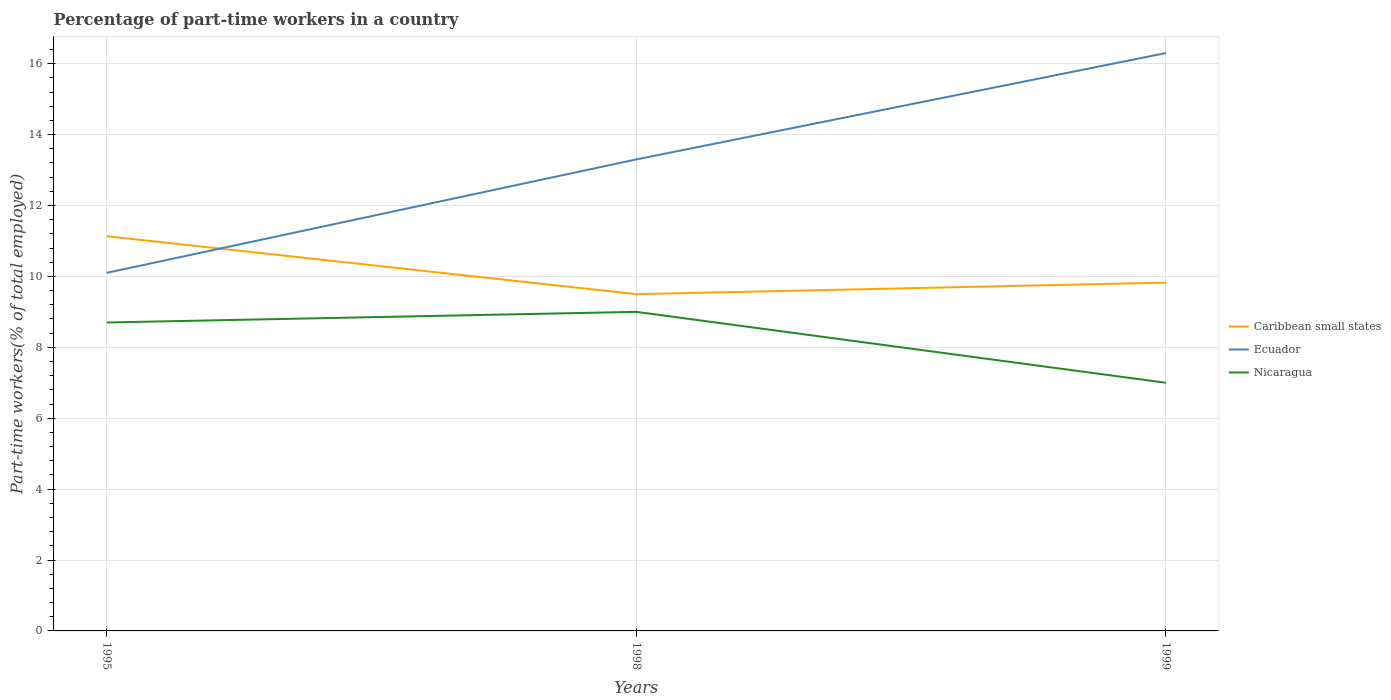How many different coloured lines are there?
Offer a very short reply. 3. Across all years, what is the maximum percentage of part-time workers in Ecuador?
Provide a succinct answer. 10.1. In which year was the percentage of part-time workers in Caribbean small states maximum?
Offer a terse response. 1998. What is the total percentage of part-time workers in Ecuador in the graph?
Provide a short and direct response. -3. What is the difference between the highest and the second highest percentage of part-time workers in Nicaragua?
Provide a short and direct response. 2. How many lines are there?
Keep it short and to the point. 3. What is the difference between two consecutive major ticks on the Y-axis?
Make the answer very short. 2. Are the values on the major ticks of Y-axis written in scientific E-notation?
Provide a short and direct response. No. Does the graph contain grids?
Your answer should be very brief. Yes. Where does the legend appear in the graph?
Keep it short and to the point. Center right. How many legend labels are there?
Your response must be concise. 3. What is the title of the graph?
Give a very brief answer. Percentage of part-time workers in a country. Does "Guatemala" appear as one of the legend labels in the graph?
Offer a terse response. No. What is the label or title of the Y-axis?
Your answer should be very brief. Part-time workers(% of total employed). What is the Part-time workers(% of total employed) of Caribbean small states in 1995?
Ensure brevity in your answer.  11.13. What is the Part-time workers(% of total employed) of Ecuador in 1995?
Ensure brevity in your answer.  10.1. What is the Part-time workers(% of total employed) of Nicaragua in 1995?
Keep it short and to the point. 8.7. What is the Part-time workers(% of total employed) in Caribbean small states in 1998?
Your response must be concise. 9.5. What is the Part-time workers(% of total employed) in Ecuador in 1998?
Your answer should be compact. 13.3. What is the Part-time workers(% of total employed) in Caribbean small states in 1999?
Your answer should be compact. 9.82. What is the Part-time workers(% of total employed) in Ecuador in 1999?
Offer a terse response. 16.3. What is the Part-time workers(% of total employed) in Nicaragua in 1999?
Your answer should be very brief. 7. Across all years, what is the maximum Part-time workers(% of total employed) in Caribbean small states?
Ensure brevity in your answer.  11.13. Across all years, what is the maximum Part-time workers(% of total employed) of Ecuador?
Your answer should be compact. 16.3. Across all years, what is the maximum Part-time workers(% of total employed) in Nicaragua?
Provide a succinct answer. 9. Across all years, what is the minimum Part-time workers(% of total employed) of Caribbean small states?
Offer a terse response. 9.5. Across all years, what is the minimum Part-time workers(% of total employed) in Ecuador?
Offer a very short reply. 10.1. Across all years, what is the minimum Part-time workers(% of total employed) in Nicaragua?
Ensure brevity in your answer.  7. What is the total Part-time workers(% of total employed) of Caribbean small states in the graph?
Ensure brevity in your answer.  30.46. What is the total Part-time workers(% of total employed) of Ecuador in the graph?
Make the answer very short. 39.7. What is the total Part-time workers(% of total employed) of Nicaragua in the graph?
Ensure brevity in your answer.  24.7. What is the difference between the Part-time workers(% of total employed) of Caribbean small states in 1995 and that in 1998?
Your answer should be compact. 1.64. What is the difference between the Part-time workers(% of total employed) in Ecuador in 1995 and that in 1998?
Your answer should be very brief. -3.2. What is the difference between the Part-time workers(% of total employed) in Nicaragua in 1995 and that in 1998?
Your answer should be compact. -0.3. What is the difference between the Part-time workers(% of total employed) in Caribbean small states in 1995 and that in 1999?
Make the answer very short. 1.31. What is the difference between the Part-time workers(% of total employed) of Ecuador in 1995 and that in 1999?
Your answer should be very brief. -6.2. What is the difference between the Part-time workers(% of total employed) in Caribbean small states in 1998 and that in 1999?
Provide a short and direct response. -0.33. What is the difference between the Part-time workers(% of total employed) of Nicaragua in 1998 and that in 1999?
Provide a succinct answer. 2. What is the difference between the Part-time workers(% of total employed) of Caribbean small states in 1995 and the Part-time workers(% of total employed) of Ecuador in 1998?
Your answer should be very brief. -2.17. What is the difference between the Part-time workers(% of total employed) of Caribbean small states in 1995 and the Part-time workers(% of total employed) of Nicaragua in 1998?
Your answer should be compact. 2.13. What is the difference between the Part-time workers(% of total employed) in Ecuador in 1995 and the Part-time workers(% of total employed) in Nicaragua in 1998?
Your answer should be very brief. 1.1. What is the difference between the Part-time workers(% of total employed) in Caribbean small states in 1995 and the Part-time workers(% of total employed) in Ecuador in 1999?
Offer a terse response. -5.17. What is the difference between the Part-time workers(% of total employed) in Caribbean small states in 1995 and the Part-time workers(% of total employed) in Nicaragua in 1999?
Your response must be concise. 4.13. What is the difference between the Part-time workers(% of total employed) of Caribbean small states in 1998 and the Part-time workers(% of total employed) of Ecuador in 1999?
Your answer should be very brief. -6.8. What is the difference between the Part-time workers(% of total employed) of Caribbean small states in 1998 and the Part-time workers(% of total employed) of Nicaragua in 1999?
Give a very brief answer. 2.5. What is the difference between the Part-time workers(% of total employed) of Ecuador in 1998 and the Part-time workers(% of total employed) of Nicaragua in 1999?
Your answer should be very brief. 6.3. What is the average Part-time workers(% of total employed) of Caribbean small states per year?
Keep it short and to the point. 10.15. What is the average Part-time workers(% of total employed) in Ecuador per year?
Keep it short and to the point. 13.23. What is the average Part-time workers(% of total employed) in Nicaragua per year?
Your answer should be compact. 8.23. In the year 1995, what is the difference between the Part-time workers(% of total employed) in Caribbean small states and Part-time workers(% of total employed) in Ecuador?
Provide a short and direct response. 1.03. In the year 1995, what is the difference between the Part-time workers(% of total employed) of Caribbean small states and Part-time workers(% of total employed) of Nicaragua?
Your answer should be very brief. 2.43. In the year 1995, what is the difference between the Part-time workers(% of total employed) in Ecuador and Part-time workers(% of total employed) in Nicaragua?
Provide a short and direct response. 1.4. In the year 1998, what is the difference between the Part-time workers(% of total employed) of Caribbean small states and Part-time workers(% of total employed) of Ecuador?
Provide a succinct answer. -3.8. In the year 1998, what is the difference between the Part-time workers(% of total employed) in Caribbean small states and Part-time workers(% of total employed) in Nicaragua?
Provide a succinct answer. 0.5. In the year 1999, what is the difference between the Part-time workers(% of total employed) of Caribbean small states and Part-time workers(% of total employed) of Ecuador?
Ensure brevity in your answer.  -6.48. In the year 1999, what is the difference between the Part-time workers(% of total employed) of Caribbean small states and Part-time workers(% of total employed) of Nicaragua?
Ensure brevity in your answer.  2.82. In the year 1999, what is the difference between the Part-time workers(% of total employed) in Ecuador and Part-time workers(% of total employed) in Nicaragua?
Your answer should be compact. 9.3. What is the ratio of the Part-time workers(% of total employed) in Caribbean small states in 1995 to that in 1998?
Provide a succinct answer. 1.17. What is the ratio of the Part-time workers(% of total employed) in Ecuador in 1995 to that in 1998?
Ensure brevity in your answer.  0.76. What is the ratio of the Part-time workers(% of total employed) of Nicaragua in 1995 to that in 1998?
Provide a short and direct response. 0.97. What is the ratio of the Part-time workers(% of total employed) of Caribbean small states in 1995 to that in 1999?
Keep it short and to the point. 1.13. What is the ratio of the Part-time workers(% of total employed) of Ecuador in 1995 to that in 1999?
Offer a terse response. 0.62. What is the ratio of the Part-time workers(% of total employed) of Nicaragua in 1995 to that in 1999?
Ensure brevity in your answer.  1.24. What is the ratio of the Part-time workers(% of total employed) of Caribbean small states in 1998 to that in 1999?
Offer a very short reply. 0.97. What is the ratio of the Part-time workers(% of total employed) in Ecuador in 1998 to that in 1999?
Your answer should be compact. 0.82. What is the ratio of the Part-time workers(% of total employed) in Nicaragua in 1998 to that in 1999?
Your answer should be very brief. 1.29. What is the difference between the highest and the second highest Part-time workers(% of total employed) of Caribbean small states?
Provide a succinct answer. 1.31. What is the difference between the highest and the second highest Part-time workers(% of total employed) in Ecuador?
Provide a succinct answer. 3. What is the difference between the highest and the lowest Part-time workers(% of total employed) of Caribbean small states?
Your answer should be compact. 1.64. What is the difference between the highest and the lowest Part-time workers(% of total employed) of Ecuador?
Keep it short and to the point. 6.2. 